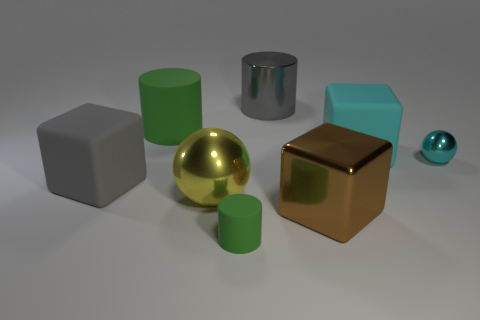Add 1 brown metal cubes. How many objects exist? 9 Subtract all cubes. How many objects are left? 5 Add 7 yellow spheres. How many yellow spheres exist? 8 Subtract 0 red blocks. How many objects are left? 8 Subtract all yellow metal objects. Subtract all spheres. How many objects are left? 5 Add 2 cubes. How many cubes are left? 5 